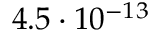Convert formula to latex. <formula><loc_0><loc_0><loc_500><loc_500>4 . 5 \cdot 1 0 ^ { - 1 3 }</formula> 